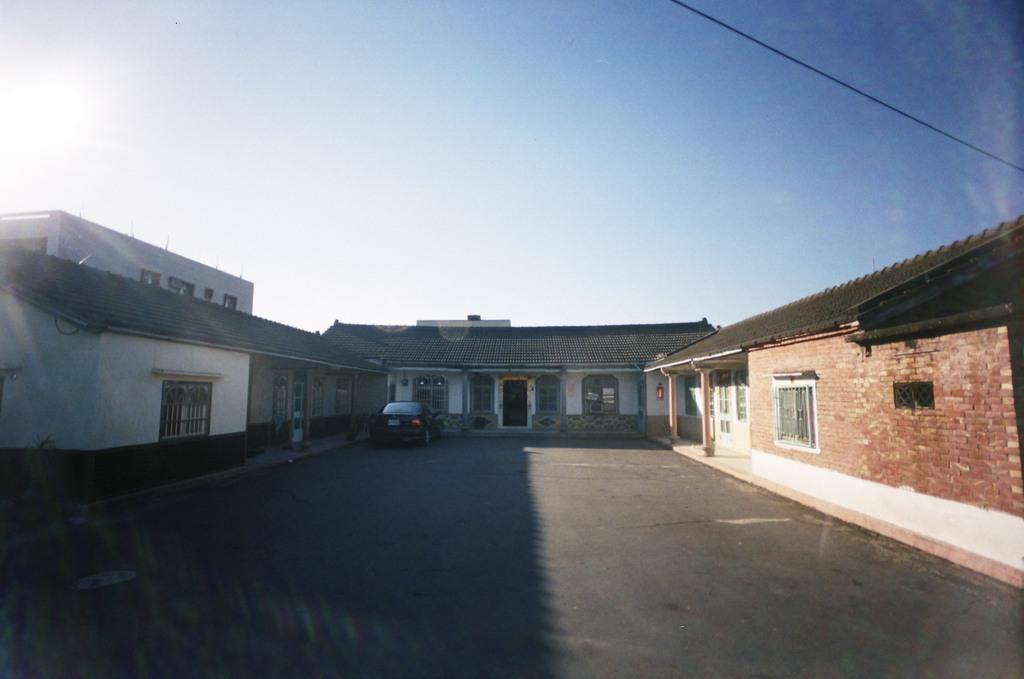What type of structures can be seen in the middle of the image? There are houses in the middle of the image. What is visible at the top of the image? The sky is visible at the top of the image. What mode of transportation can be seen in the middle of the image? There is a car in the middle of the image. Where is the iron located in the image? There is no iron present in the image. What type of balls can be seen in the image? There are no balls present in the image. 